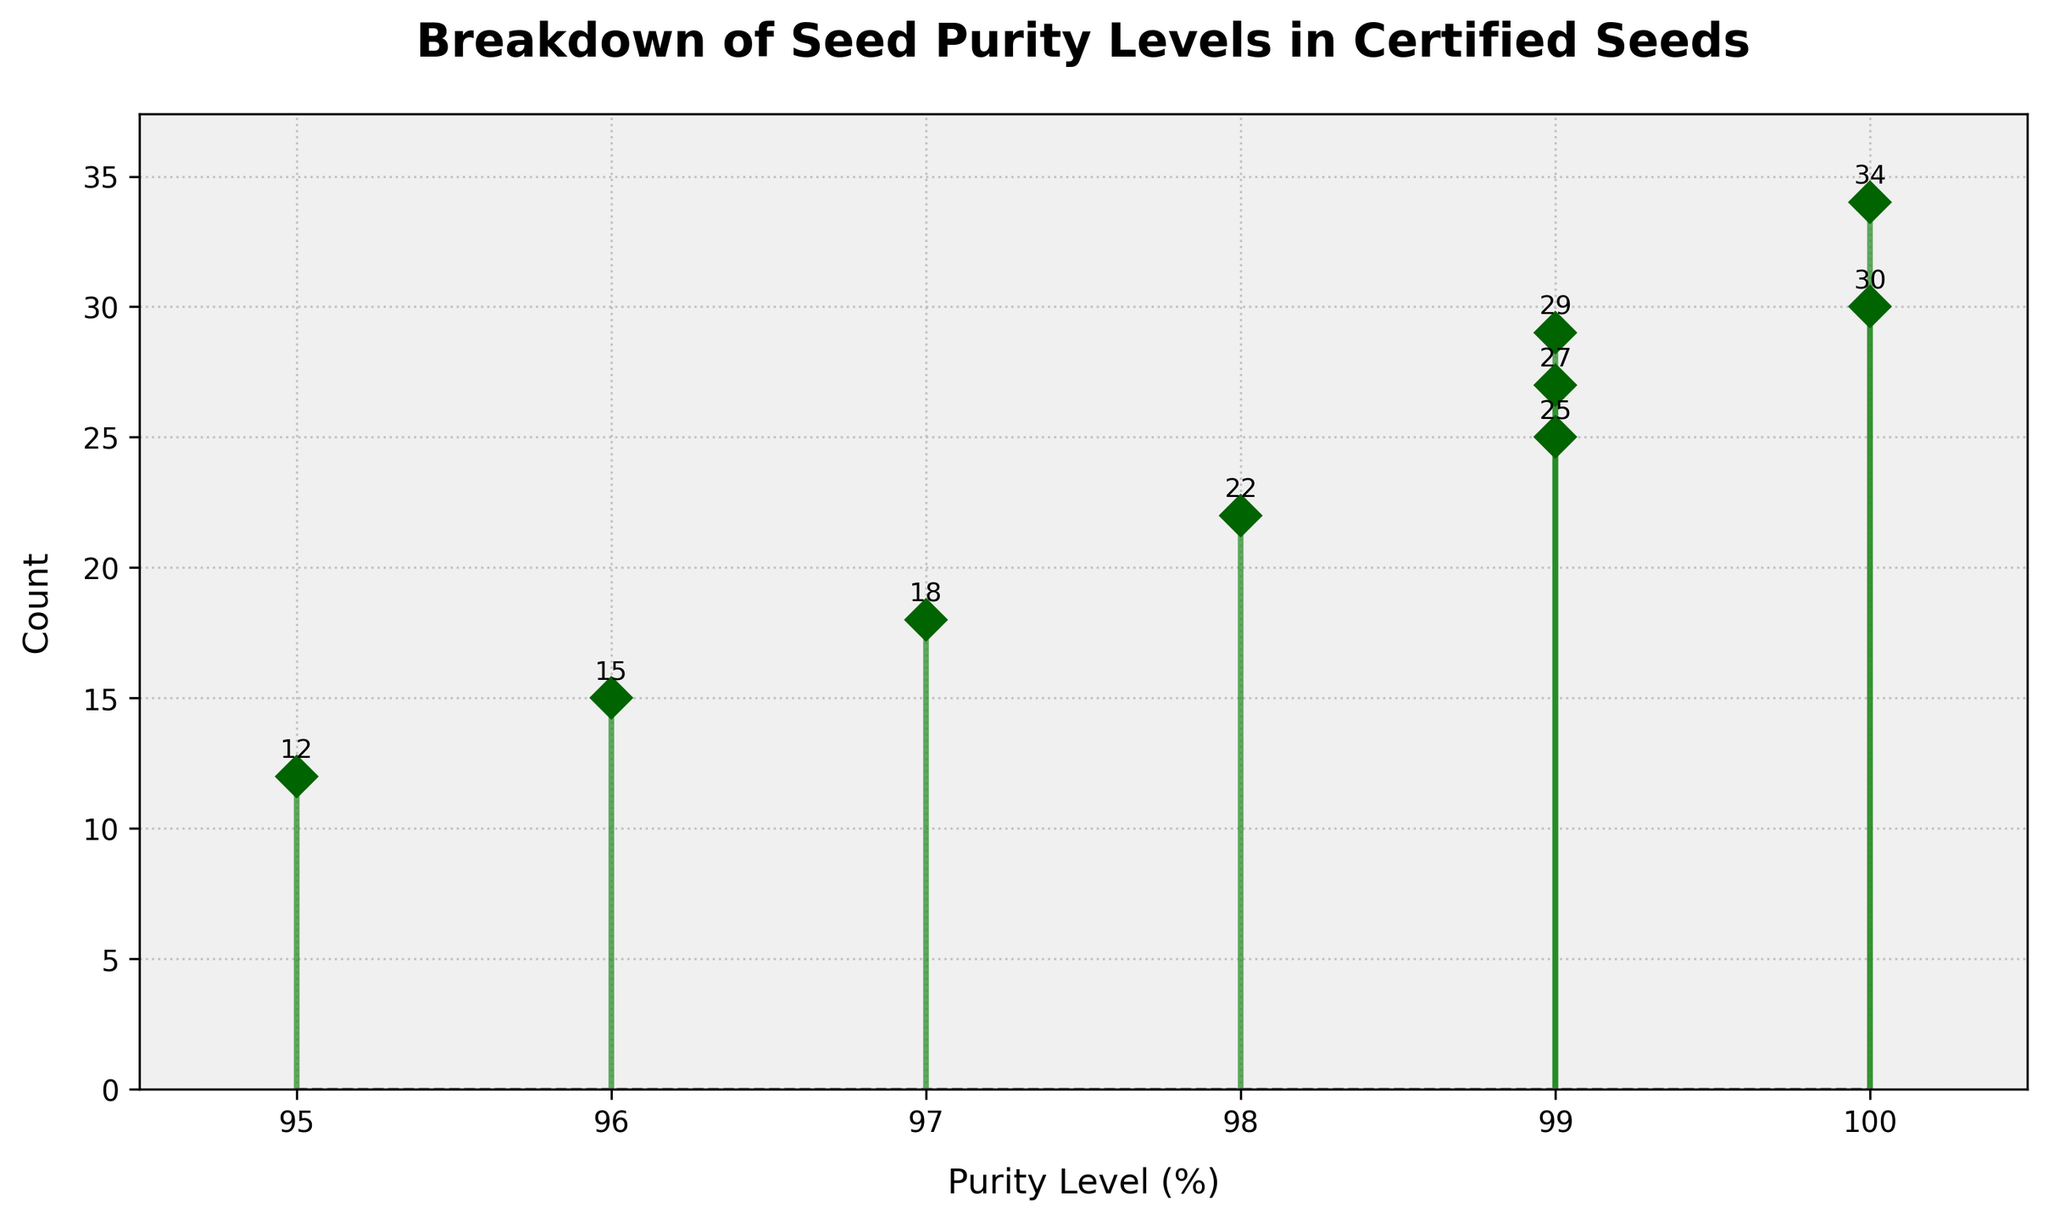What is the title of the stem plot? The title is displayed at the top of the plot in bold and larger font text. It reads 'Breakdown of Seed Purity Levels in Certified Seeds'.
Answer: Breakdown of Seed Purity Levels in Certified Seeds What are the labels of the x-axis and y-axis? The x-axis label is positioned below the x-axis and reads 'Purity Level (%)'. The y-axis label is positioned to the left of the y-axis and reads 'Count'.
Answer: Purity Level (%) and Count How many data points are represented in the plot? By counting the number of vertical lines (stems) in the plot, which represent each Purity Level, there are 9 data points shown.
Answer: 9 What is the highest count observed in the plot? The vertical position (height) of each marker indicates the Count. The highest position is 34, which is indicated above the data point where Purity Level is 100%.
Answer: 34 Which Purity Level has the lowest count and what is that count? The lowest count can be found by identifying the shortest stem. The shortest stem corresponds to the Purity Level of 95% with a count of 12.
Answer: 95%, 12 What's the average count of all data points? Add up all counts: 12 + 15 + 18 + 22 + 25 + 27 + 29 + 30 + 34 = 212. There are 9 data points. Divide the total count by the number of data points: 212 / 9 ≈ 23.56.
Answer: 23.56 Which Purity Level has the most variation in counts? By checking the Purity Levels that appear more than once, 99% Purity Level has three different counts: 25, 27, and 29.
Answer: 99% What is the difference in count between the highest and lowest Purity Levels? The count at 100% Purity Level is 34, and at 95% Purity Level it is 12. Calculate the difference: 34 - 12 = 22.
Answer: 22 How many counts are over 20? Identify the number of data points where the Count is above 20: 22, 25, 27, 29, 30, and 34. There are 6 such data points.
Answer: 6 Are there any Purity Levels with an equal count, and if so, which ones? By checking the counts at each Purity Level, there are no Purity Levels that have the same count. Each Purity Level has a unique count in this plot.
Answer: No 